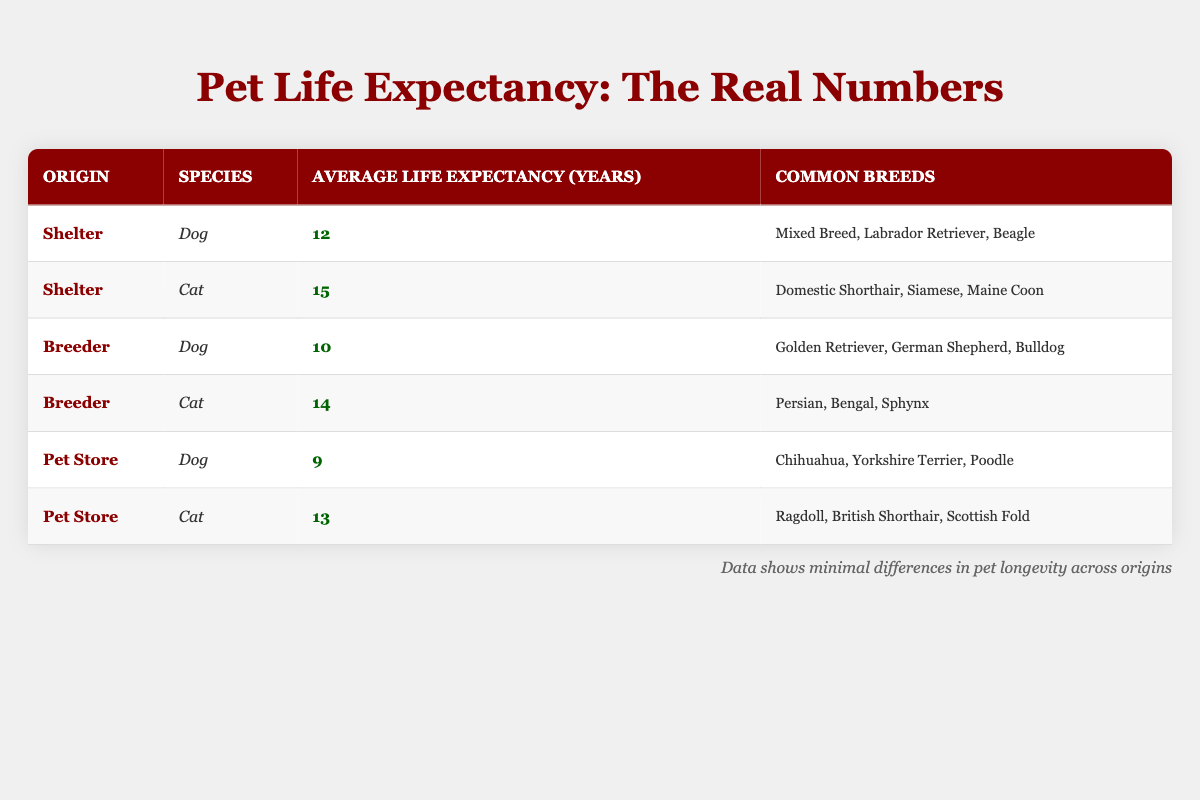What is the average life expectancy of dogs from a shelter? From the table, the average life expectancy for dogs from a shelter is listed as 12 years.
Answer: 12 years Which origin has the highest average life expectancy for cats? Looking at the table, cats from shelters have the highest average life expectancy at 15 years compared to breeder cats at 14 years and pet store cats at 13 years.
Answer: Shelter What is the average life expectancy of dogs from a breeder compared to those from a pet store? The average life expectancy for dogs from a breeder is 10 years, while for those from pet stores, it is 9 years. Therefore, dogs from breeders live, on average, 1 year longer than those from pet stores.
Answer: 1 year Are cats from pet stores expected to live longer than cats from breeders? The average life expectancy for cats from pet stores is 13 years, while for breeders, it is 14 years; therefore, cats from pet stores do not live longer than those from breeders.
Answer: No What is the difference in average life expectancy of dogs from shelters and pet stores? Dogs from shelters have an average life expectancy of 12 years, while dogs from pet stores have an average of 9 years. The difference is calculated as 12 - 9 = 3 years.
Answer: 3 years If a person chooses to adopt a dog from a shelter, how much longer can they expect the dog to live compared to adopting from a pet store? The average life expectancy for a dog from a shelter is 12 years, and for a dog from a pet store, it is 9 years. Subtracting these gives 12 - 9 = 3 years, indicating longer life expectancy with shelter adoption.
Answer: 3 years Considering all types of pets, which species generally has the highest average life expectancy at pet stores? The table indicates that cats from pet stores have an average life expectancy of 13 years, while dogs from the same origin have 9 years; therefore, cats live longer than dogs at pet stores.
Answer: Cats What is the average life expectancy for all cats listed in the table? To find the average life expectancy for all cats, we take the total life expectancies: 15 years (shelter) + 14 years (breeder) + 13 years (pet store) = 42 years. Dividing by the number of categories (3) gives an average of 42 / 3 = 14 years.
Answer: 14 years Do dogs from breeders have a longer average life expectancy than dogs from shelters? From the table, dogs from breeders average 10 years whereas dogs from shelters average 12 years. Therefore, dogs from breeders do not live longer than those from shelters.
Answer: No 